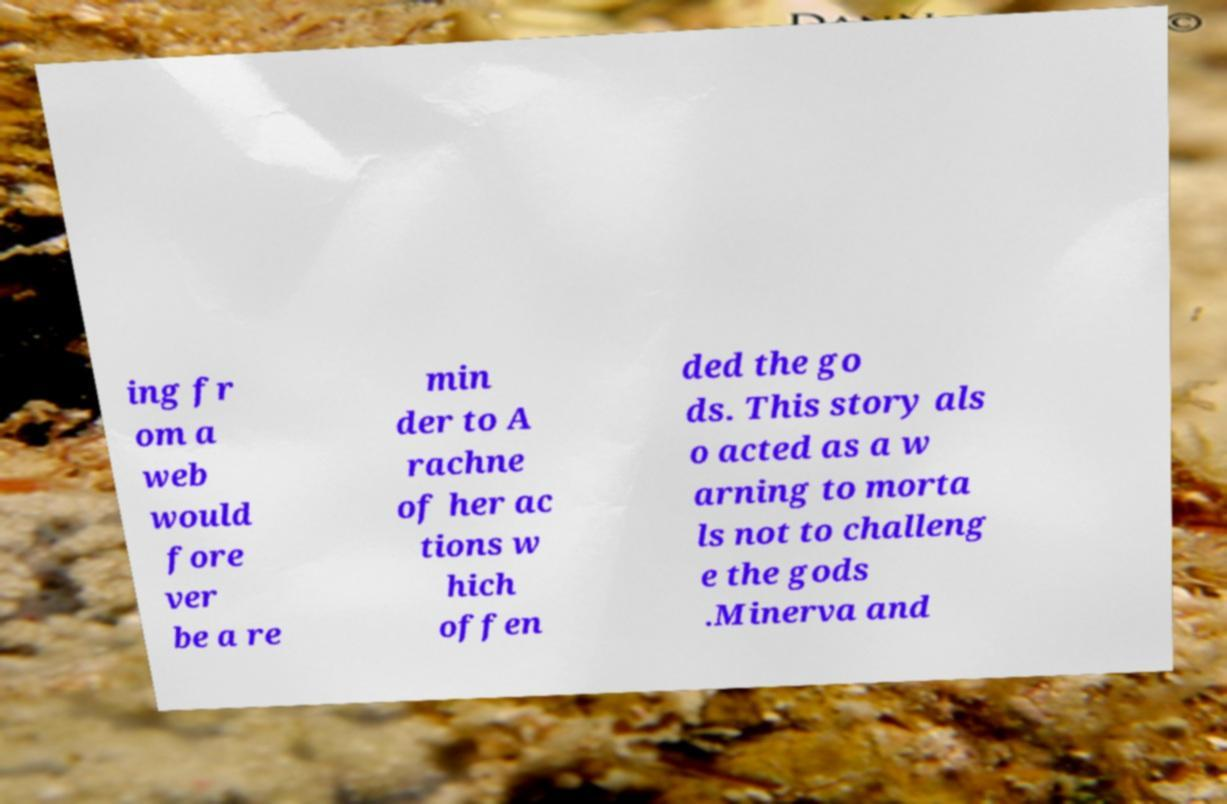Could you assist in decoding the text presented in this image and type it out clearly? ing fr om a web would fore ver be a re min der to A rachne of her ac tions w hich offen ded the go ds. This story als o acted as a w arning to morta ls not to challeng e the gods .Minerva and 